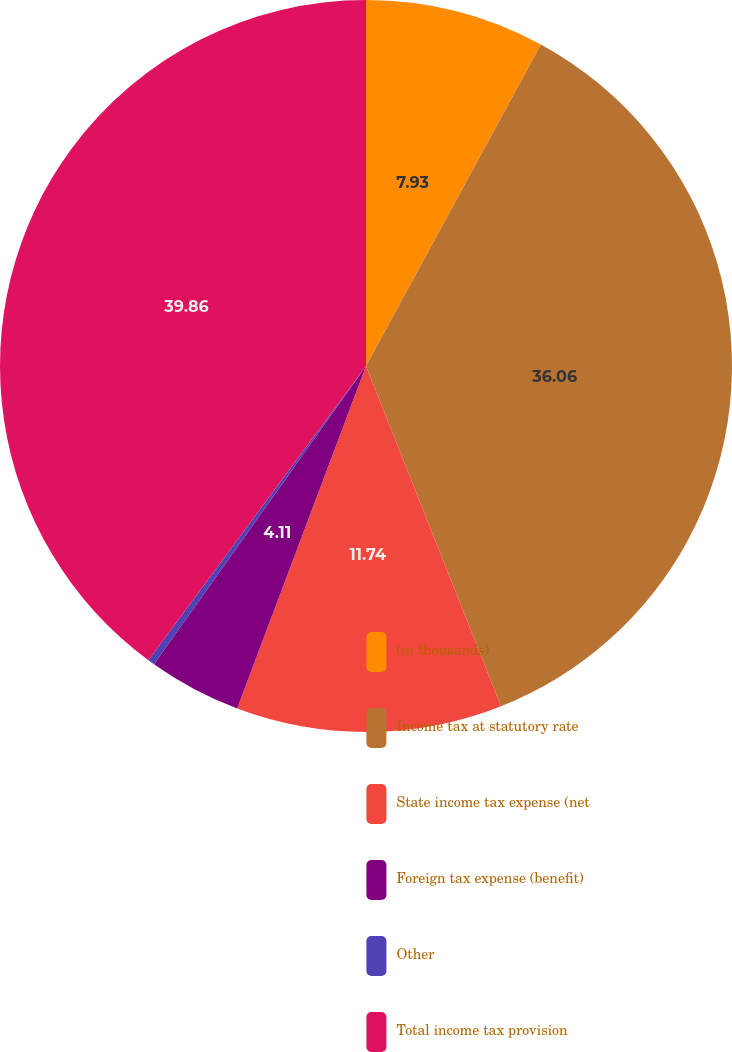Convert chart to OTSL. <chart><loc_0><loc_0><loc_500><loc_500><pie_chart><fcel>(in thousands)<fcel>Income tax at statutory rate<fcel>State income tax expense (net<fcel>Foreign tax expense (benefit)<fcel>Other<fcel>Total income tax provision<nl><fcel>7.93%<fcel>36.06%<fcel>11.74%<fcel>4.11%<fcel>0.3%<fcel>39.87%<nl></chart> 